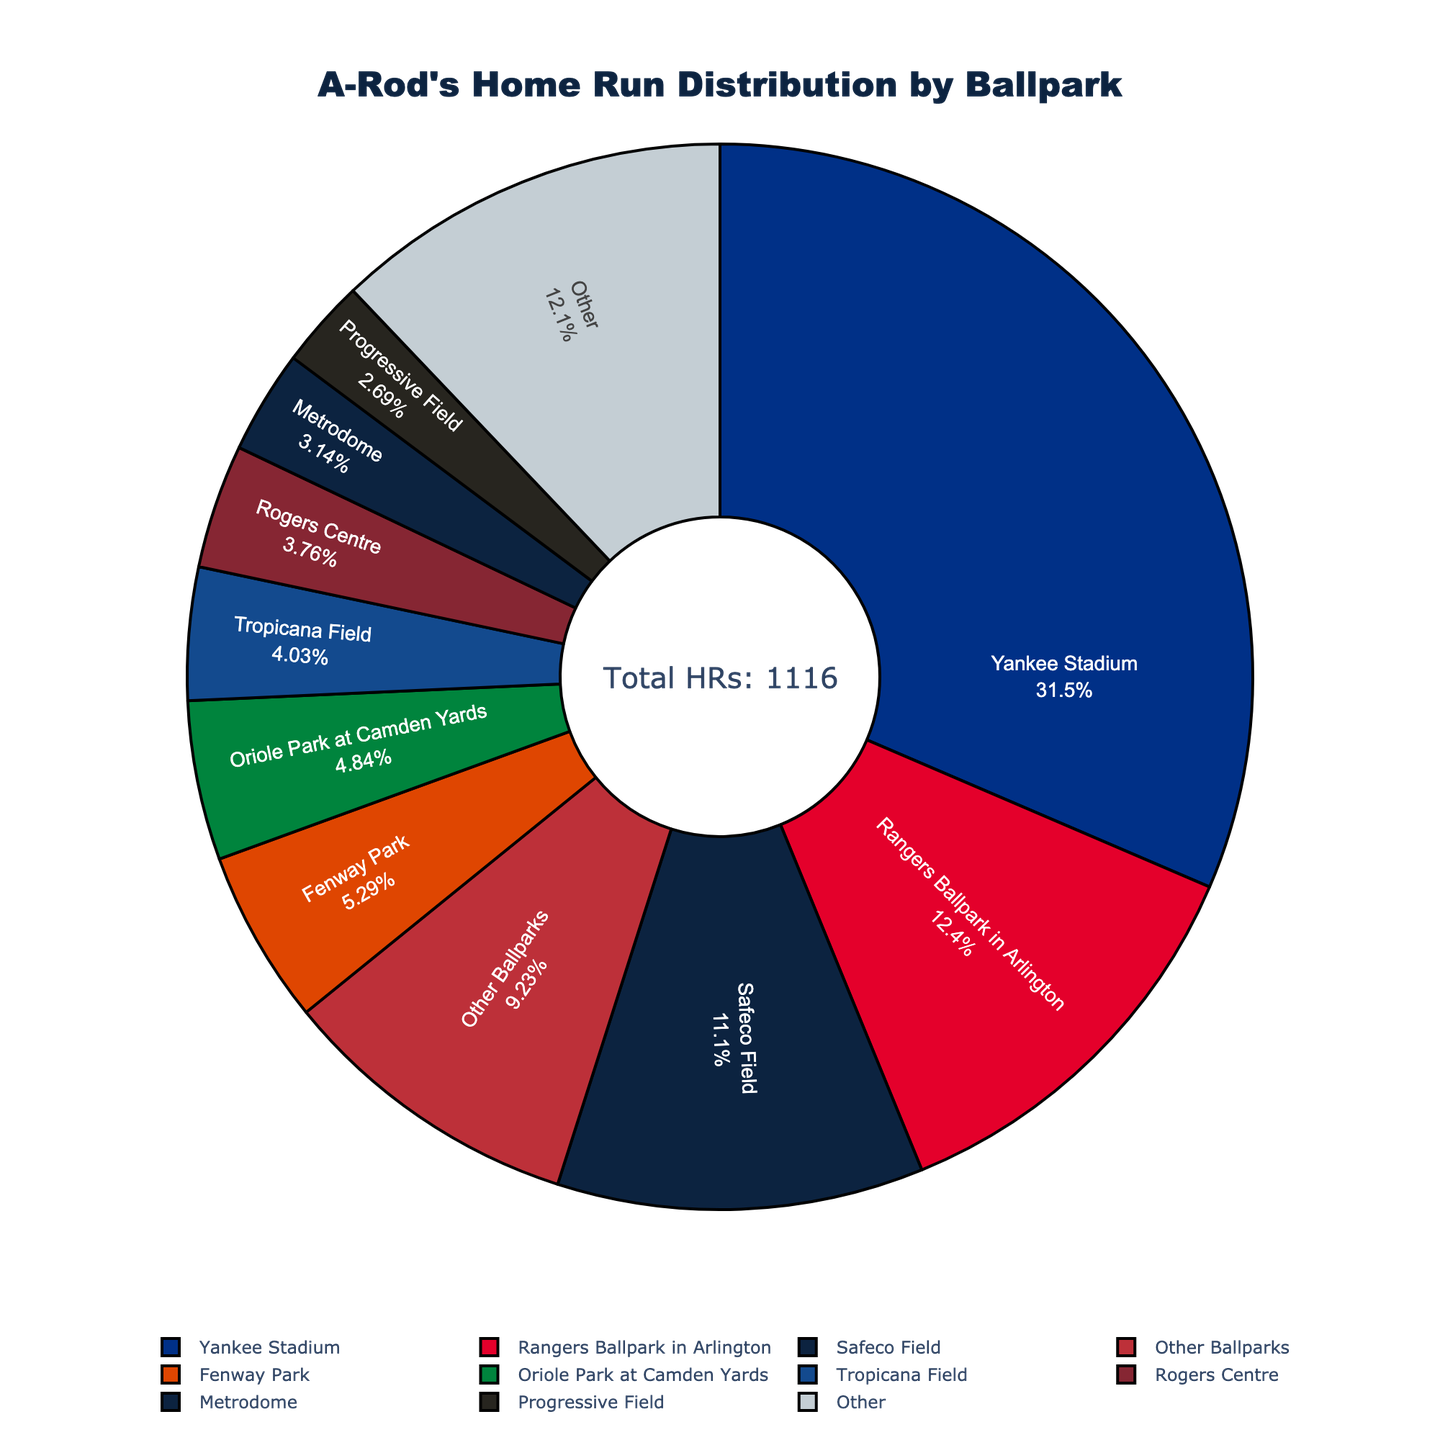Which ballpark did A-Rod hit the most home runs in? The largest section of the pie chart is labeled 'Yankee Stadium'.
Answer: Yankee Stadium What is the total number of home runs A-Rod hit at Yankee Stadium and Rangers Ballpark in Arlington? The number of home runs at Yankee Stadium is 351 and at Rangers Ballpark in Arlington is 138. Adding them together gives 351 + 138 = 489.
Answer: 489 Which ballpark contributed the smallest slice among the top 10 ballparks? The smallest slice among the top 10 ballparks is labeled 'U.S. Cellular Field'.
Answer: U.S. Cellular Field How many home runs did A-Rod hit at ballparks outside the top 10 listed? The slice labeled 'Other' in the pie chart represents ballparks outside the top 10 and is labeled with 103 home runs.
Answer: 103 Compare the home runs hit at Fenway Park and Oriole Park at Camden Yards. Which one is higher and by how much? Fenway Park shows 59 home runs, while Oriole Park at Camden Yards shows 54 home runs. The difference is 59 - 54 = 5. Fenway Park has 5 more home runs than Oriole Park at Camden Yards.
Answer: Fenway Park by 5 What percentage of A-Rod's total 1116 home runs were hit at Safeco Field? Safeco Field is labeled with 124 home runs. The percentage is calculated as (124 / 1116) * 100 ≈ 11.1%.
Answer: 11.1% What is the combined number of home runs A-Rod hit in Tropicana Field, Rogers Centre, and Metrodome? The segment for Tropicana Field shows 45 home runs, Rogers Centre shows 42 home runs, and Metrodome shows 35 home runs. Adding these gives 45 + 42 + 35 = 122.
Answer: 122 Is the number of home runs hit at Angel Stadium greater than or less than that at Kauffman Stadium? Angel Stadium has 23 home runs, while Kauffman Stadium has 24 home runs. Comparatively, 23 is less than 24.
Answer: Less than What is the percentage of total home runs hit at Yankee Stadium? Yankee Stadium is labeled with 351 home runs. The percentage is calculated as (351 / 1116) * 100 ≈ 31.45%.
Answer: 31.45% If A-Rod hit 30 home runs at Progressive Field, what fraction of his total career home runs were made at this ballpark? Progressive Field shows 30 home runs. The fraction is 30 / 1116, which simplifies to approximately 1 / 37.2.
Answer: 1/37.2 